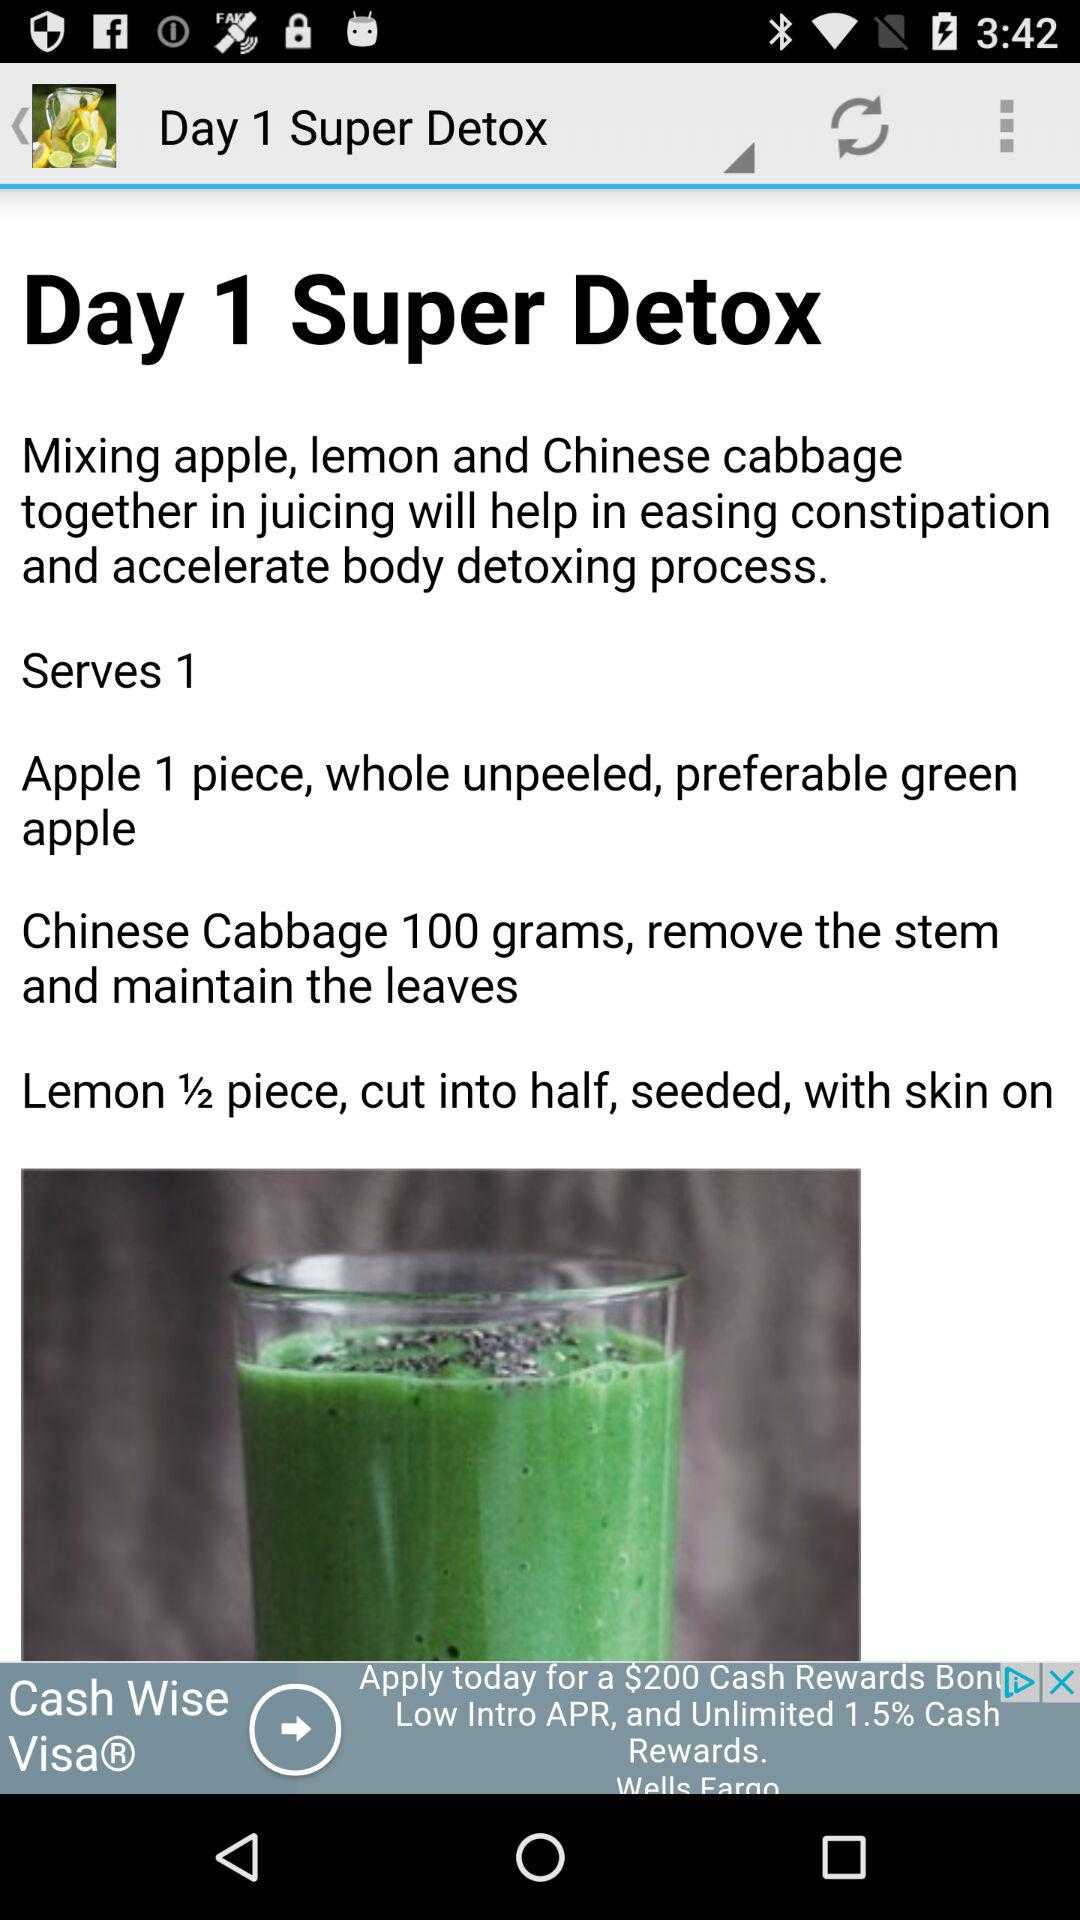How many grams of Chinese cabbage are used in this recipe?
Answer the question using a single word or phrase. 100 